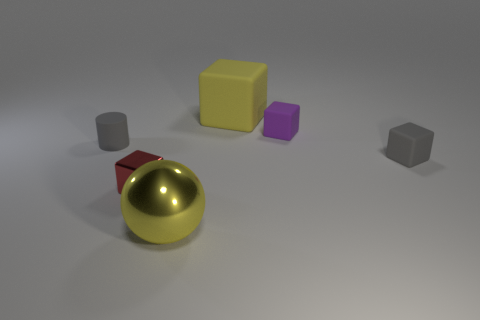Subtract all brown cylinders. Subtract all blue blocks. How many cylinders are left? 1 Add 1 tiny blocks. How many objects exist? 7 Subtract all cylinders. How many objects are left? 5 Add 5 tiny gray matte cylinders. How many tiny gray matte cylinders are left? 6 Add 3 purple objects. How many purple objects exist? 4 Subtract 1 gray cylinders. How many objects are left? 5 Subtract all tiny green objects. Subtract all gray cylinders. How many objects are left? 5 